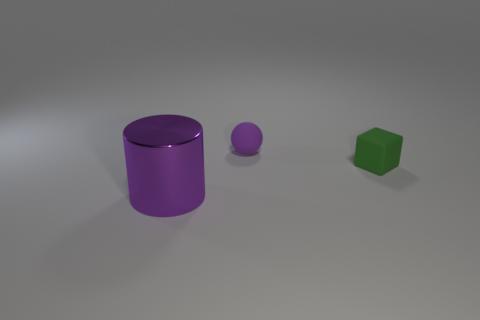What can you tell me about the lighting in this scene? The lighting in the scene appears to be coming from above, casting soft shadows below the objects. The overall effect gives the image a calm and muted ambiance. 